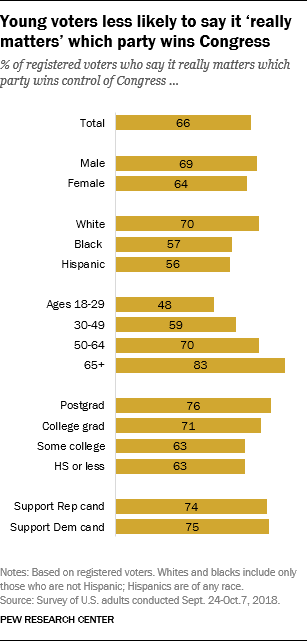Draw attention to some important aspects in this diagram. The total amount of support for the "Support Rep" and "Support Dem" candidates is 149. The value of Male is 69. 